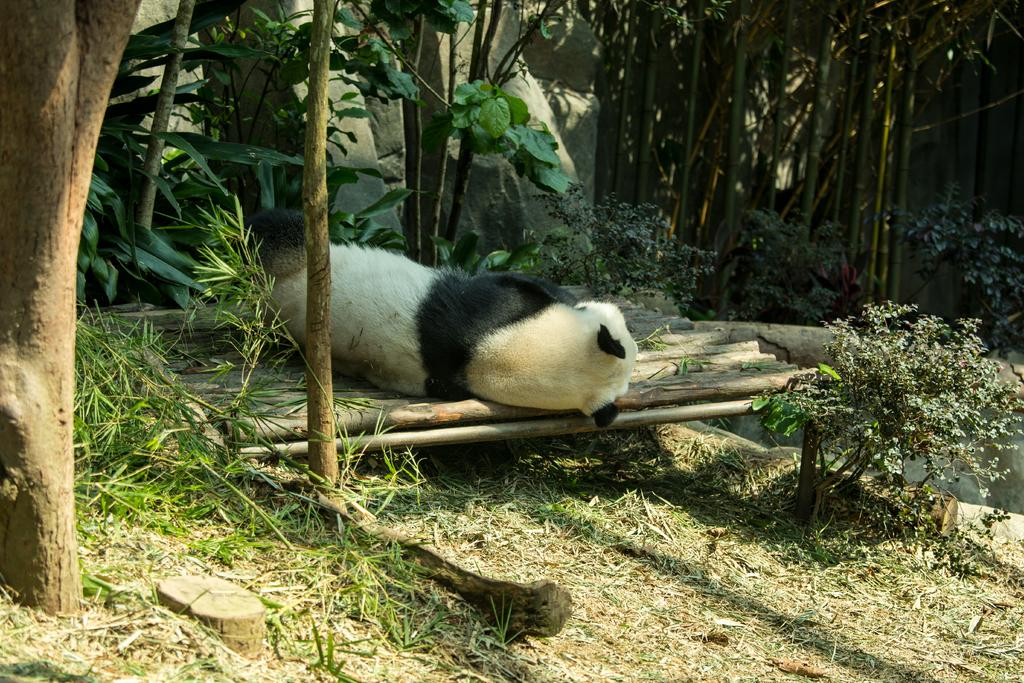What is the main subject of the image? There is an animal laying on a wooden stand in the image. What type of vegetation can be seen in the image? There are plants and trees visible in the image. What is the natural setting visible in the image? The background of the image includes rocks. What type of shoes can be seen on the animal in the image? There are no shoes visible on the animal in the image. Is there a bear present in the image? There is no bear present in the image; the main subject is an animal laying on a wooden stand. 